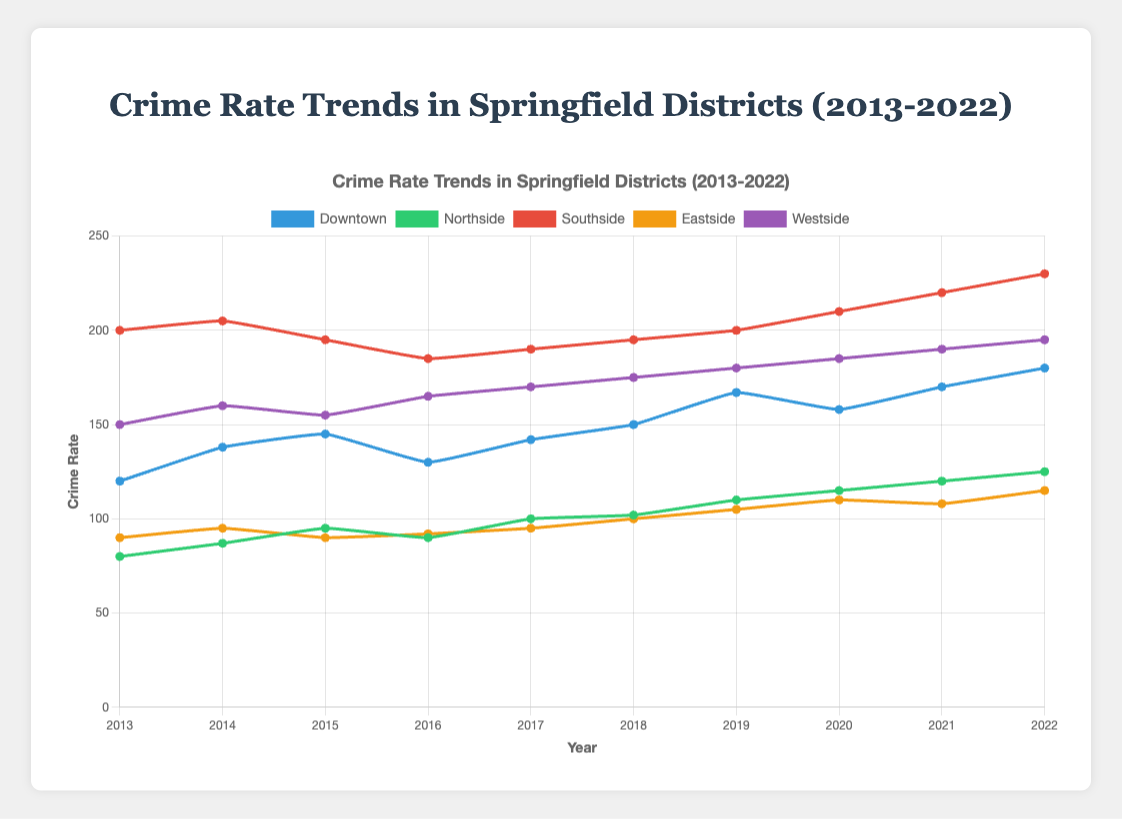Which district had the highest crime rate in 2022? From the chart, we can identify the highest point on the y-axis for the year 2022 among all the districts. Southside's crime rate in 2022 reaches 230, which is the highest.
Answer: Southside How did the crime rate in Downtown change from 2013 to 2016? To find the change, look at the crime rates for Downtown in 2013 and 2016. The crime rates were 120 in 2013 and 130 in 2016. Calculate the difference: 130 - 120 = 10. So, the crime rate increased by 10.
Answer: Increased by 10 What is the average crime rate in Westside from 2015 to 2022? Find the crime rates for Westside from 2015 to 2022: 155, 165, 170, 175, 180, 185, 190, 195. Sum these values and divide by the number of years (8). Sum = 1415. Average = 1415 / 8 = 176.875.
Answer: 176.875 In which year did Northside's crime rate surpass 100? Examine Northside's crime rates across the years and identify the first year it exceeds 100. Northside's crime rate was over 100 in 2017 for the first time.
Answer: 2017 Which two districts had almost similar crime rates in 2020? Compare the crime rates of all districts for the year 2020. Downtown had 158 and Eastside had 160, Southside had 210, Northside had 115, Westside had 185. Downtown and Eastside are relatively close.
Answer: Downtown and Eastside By how much did the crime rate in Southside increase from 2018 to 2022? Compare Southside’s crime rates in 2018 and 2022. The rates are 195 in 2018 and 230 in 2022. Calculate the difference: 230 - 195 = 35.
Answer: Increased by 35 What trend do you observe for Northside's crime rate from 2013 to 2022? Observe Northside's line in the graph. Starting from 80 in 2013, it continuously increases each year until it reaches 125 in 2022. The trend is a steady increase.
Answer: Steady increase Which district had the lowest crime rate in 2015? Reference the year 2015 and compare the crime rates of all districts. The crime rates are Downtown - 145, Northside - 95, Southside - 195, Eastside - 90, Westside - 155. Eastside has the lowest crime rate of 90.
Answer: Eastside What is the sum of the 2019 crime rates for all districts? Find each district’s crime rate for 2019, then sum them up. The values are Downtown - 167, Northside - 110, Southside - 200, Eastside - 105, Westside - 180. Sum = 167 + 110 + 200 + 105 + 180 = 762.
Answer: 762 Which district showed a decline in crime rate from 2021 to 2022? Compare the crime rates for all districts between 2021 and 2022. Downtown increased from 170 to 180; Northside increased from 120 to 125; Southside increased from 220 to 230; Eastside increased from 108 to 115; Westside increased from 190 to 195. None of the districts showed a decline.
Answer: None 